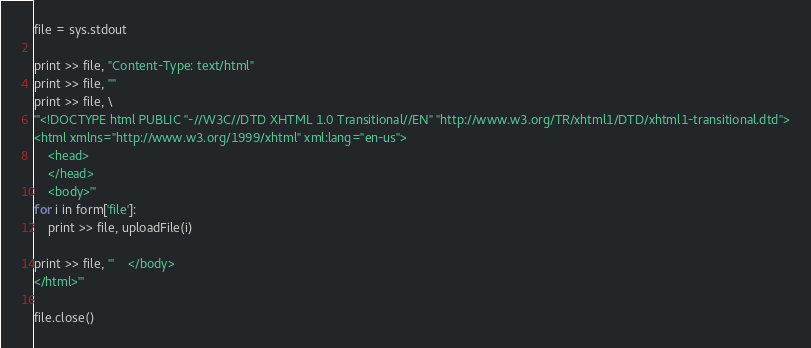Convert code to text. <code><loc_0><loc_0><loc_500><loc_500><_Python_>
file = sys.stdout

print >> file, "Content-Type: text/html"
print >> file, ""
print >> file, \
'''<!DOCTYPE html PUBLIC "-//W3C//DTD XHTML 1.0 Transitional//EN" "http://www.w3.org/TR/xhtml1/DTD/xhtml1-transitional.dtd">
<html xmlns="http://www.w3.org/1999/xhtml" xml:lang="en-us">
    <head> 
	</head>
	<body>'''
for i in form['file']:
	print >> file, uploadFile(i)

print >> file, '''	</body>
</html>'''

file.close()
</code> 